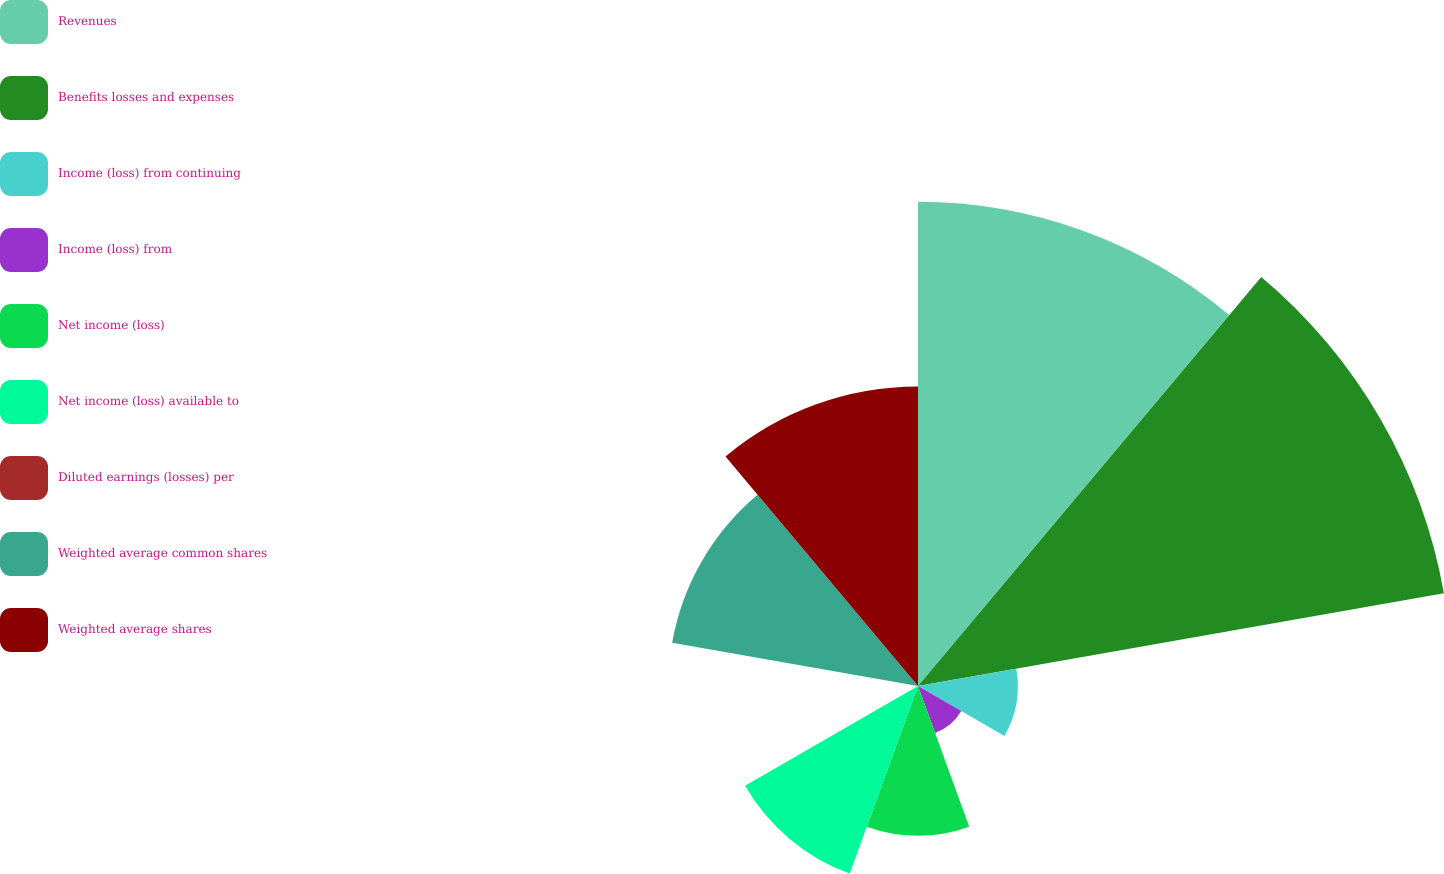Convert chart to OTSL. <chart><loc_0><loc_0><loc_500><loc_500><pie_chart><fcel>Revenues<fcel>Benefits losses and expenses<fcel>Income (loss) from continuing<fcel>Income (loss) from<fcel>Net income (loss)<fcel>Net income (loss) available to<fcel>Diluted earnings (losses) per<fcel>Weighted average common shares<fcel>Weighted average shares<nl><fcel>23.43%<fcel>25.84%<fcel>4.83%<fcel>2.42%<fcel>7.25%<fcel>9.66%<fcel>0.0%<fcel>12.08%<fcel>14.49%<nl></chart> 